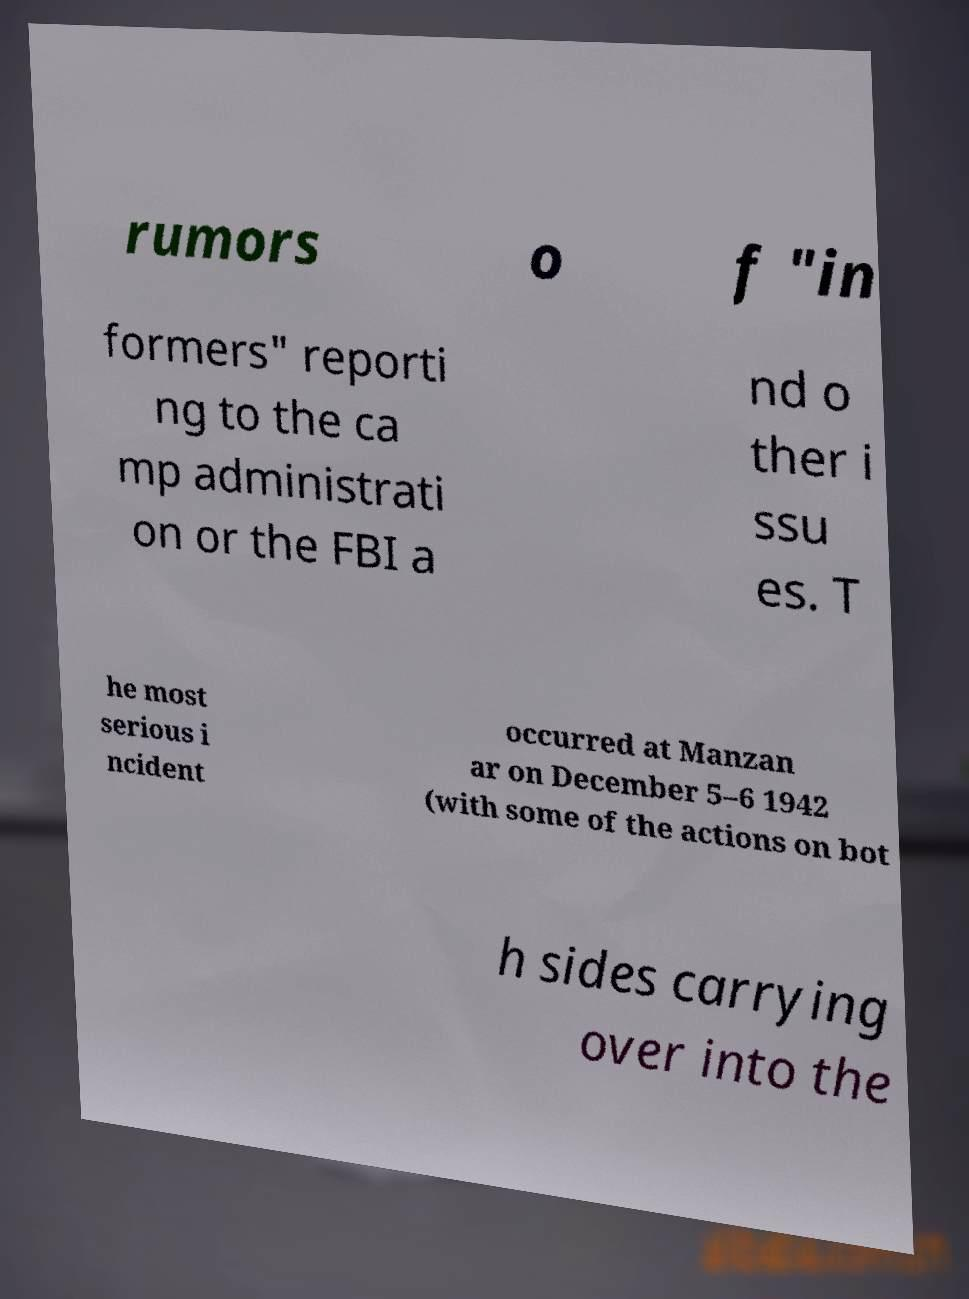Please read and relay the text visible in this image. What does it say? rumors o f "in formers" reporti ng to the ca mp administrati on or the FBI a nd o ther i ssu es. T he most serious i ncident occurred at Manzan ar on December 5–6 1942 (with some of the actions on bot h sides carrying over into the 